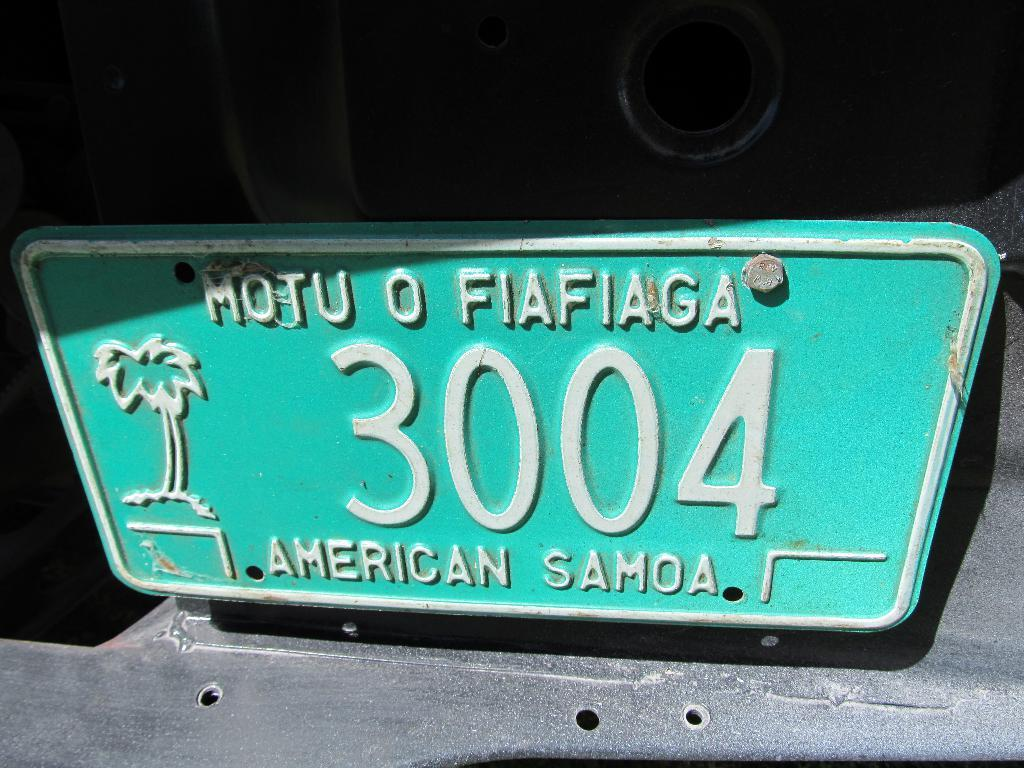What is the main object in the image? There is a board in the image. What is written or displayed on the board? There is text on the board. How much rice is visible on the board in the image? There is no rice present on the board in the image. What type of underwear is hanging on the board in the image? There is no underwear present on the board in the image. 